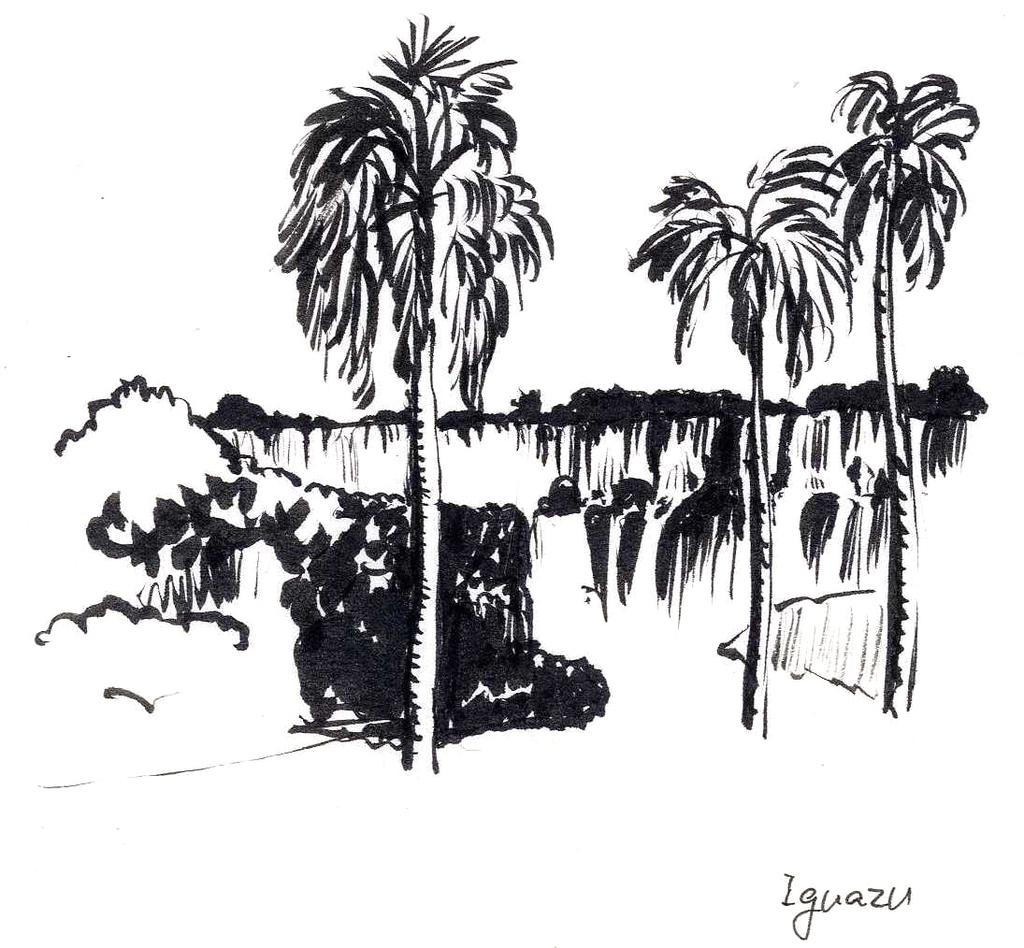What is depicted in the sketch in the image? There is a sketch of trees and a mountain in the image. Where is the text located in the image? The text is at the bottom right of the image. How does the writer's health affect the sketch of the mountain in the image? There is no writer present in the image, and therefore no information about their health can be used to interpret the sketch of the mountain. 